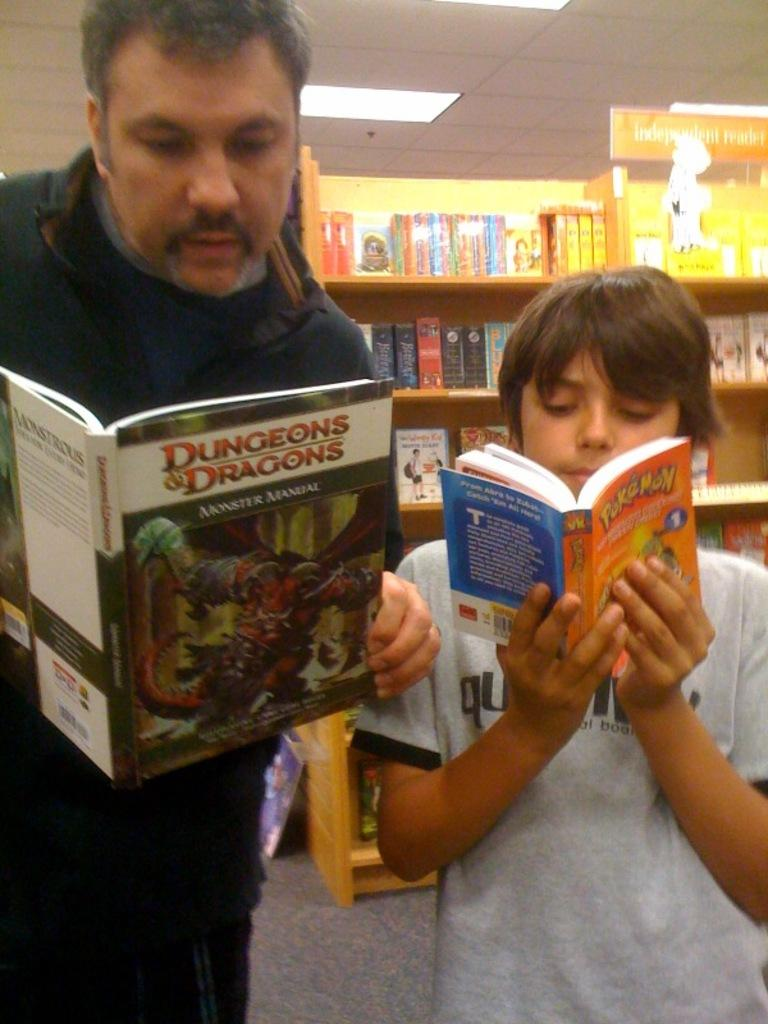<image>
Write a terse but informative summary of the picture. Two boys reading books on Dungeons & Dragons and Pokemon. 